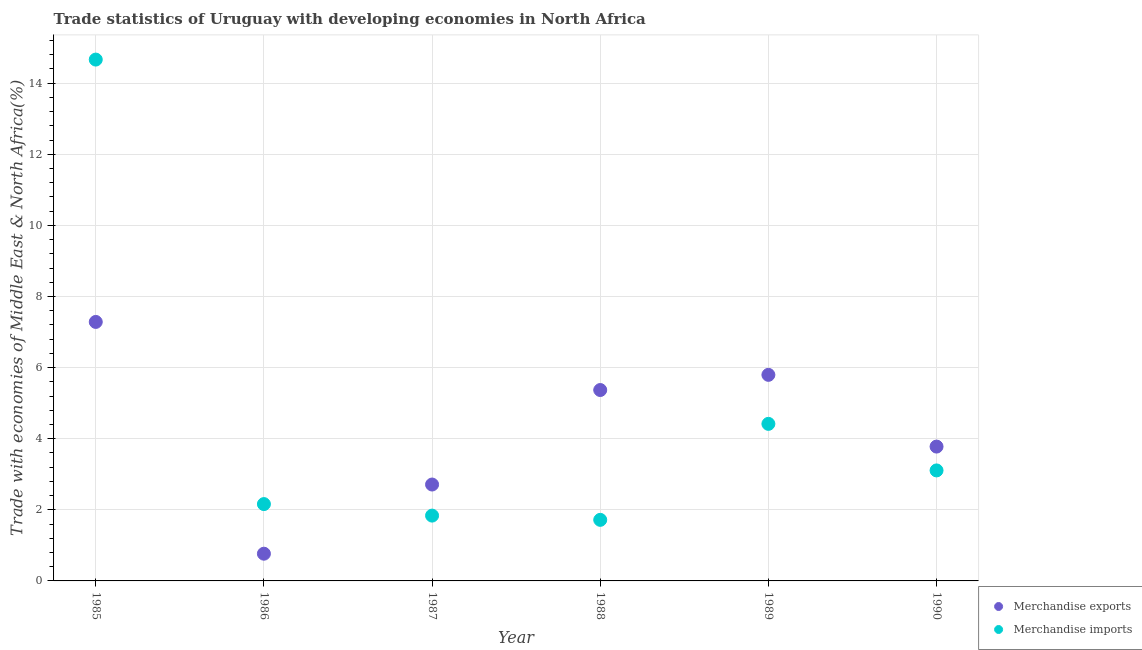What is the merchandise imports in 1987?
Your answer should be very brief. 1.84. Across all years, what is the maximum merchandise exports?
Offer a very short reply. 7.28. Across all years, what is the minimum merchandise exports?
Offer a very short reply. 0.77. In which year was the merchandise imports maximum?
Provide a succinct answer. 1985. What is the total merchandise exports in the graph?
Provide a succinct answer. 25.7. What is the difference between the merchandise exports in 1988 and that in 1990?
Offer a terse response. 1.59. What is the difference between the merchandise exports in 1989 and the merchandise imports in 1987?
Your answer should be compact. 3.96. What is the average merchandise imports per year?
Provide a succinct answer. 4.65. In the year 1985, what is the difference between the merchandise exports and merchandise imports?
Give a very brief answer. -7.38. In how many years, is the merchandise imports greater than 12 %?
Give a very brief answer. 1. What is the ratio of the merchandise imports in 1989 to that in 1990?
Keep it short and to the point. 1.42. Is the difference between the merchandise imports in 1988 and 1989 greater than the difference between the merchandise exports in 1988 and 1989?
Provide a succinct answer. No. What is the difference between the highest and the second highest merchandise exports?
Your response must be concise. 1.49. What is the difference between the highest and the lowest merchandise exports?
Your answer should be very brief. 6.52. Is the sum of the merchandise imports in 1987 and 1990 greater than the maximum merchandise exports across all years?
Offer a terse response. No. Does the merchandise imports monotonically increase over the years?
Ensure brevity in your answer.  No. Is the merchandise imports strictly less than the merchandise exports over the years?
Give a very brief answer. No. How many dotlines are there?
Provide a succinct answer. 2. How many years are there in the graph?
Offer a terse response. 6. What is the difference between two consecutive major ticks on the Y-axis?
Provide a succinct answer. 2. Does the graph contain grids?
Give a very brief answer. Yes. How many legend labels are there?
Offer a terse response. 2. What is the title of the graph?
Offer a very short reply. Trade statistics of Uruguay with developing economies in North Africa. Does "National Tourists" appear as one of the legend labels in the graph?
Keep it short and to the point. No. What is the label or title of the Y-axis?
Ensure brevity in your answer.  Trade with economies of Middle East & North Africa(%). What is the Trade with economies of Middle East & North Africa(%) in Merchandise exports in 1985?
Your answer should be compact. 7.28. What is the Trade with economies of Middle East & North Africa(%) of Merchandise imports in 1985?
Offer a terse response. 14.66. What is the Trade with economies of Middle East & North Africa(%) of Merchandise exports in 1986?
Offer a very short reply. 0.77. What is the Trade with economies of Middle East & North Africa(%) of Merchandise imports in 1986?
Give a very brief answer. 2.16. What is the Trade with economies of Middle East & North Africa(%) in Merchandise exports in 1987?
Your answer should be very brief. 2.71. What is the Trade with economies of Middle East & North Africa(%) of Merchandise imports in 1987?
Your answer should be compact. 1.84. What is the Trade with economies of Middle East & North Africa(%) of Merchandise exports in 1988?
Offer a very short reply. 5.37. What is the Trade with economies of Middle East & North Africa(%) of Merchandise imports in 1988?
Your answer should be very brief. 1.72. What is the Trade with economies of Middle East & North Africa(%) in Merchandise exports in 1989?
Ensure brevity in your answer.  5.8. What is the Trade with economies of Middle East & North Africa(%) in Merchandise imports in 1989?
Offer a terse response. 4.42. What is the Trade with economies of Middle East & North Africa(%) in Merchandise exports in 1990?
Provide a succinct answer. 3.78. What is the Trade with economies of Middle East & North Africa(%) in Merchandise imports in 1990?
Your answer should be compact. 3.11. Across all years, what is the maximum Trade with economies of Middle East & North Africa(%) of Merchandise exports?
Keep it short and to the point. 7.28. Across all years, what is the maximum Trade with economies of Middle East & North Africa(%) of Merchandise imports?
Your answer should be compact. 14.66. Across all years, what is the minimum Trade with economies of Middle East & North Africa(%) of Merchandise exports?
Your answer should be very brief. 0.77. Across all years, what is the minimum Trade with economies of Middle East & North Africa(%) of Merchandise imports?
Provide a succinct answer. 1.72. What is the total Trade with economies of Middle East & North Africa(%) of Merchandise exports in the graph?
Your answer should be compact. 25.7. What is the total Trade with economies of Middle East & North Africa(%) in Merchandise imports in the graph?
Your answer should be very brief. 27.9. What is the difference between the Trade with economies of Middle East & North Africa(%) in Merchandise exports in 1985 and that in 1986?
Your answer should be very brief. 6.52. What is the difference between the Trade with economies of Middle East & North Africa(%) in Merchandise imports in 1985 and that in 1986?
Ensure brevity in your answer.  12.5. What is the difference between the Trade with economies of Middle East & North Africa(%) of Merchandise exports in 1985 and that in 1987?
Offer a very short reply. 4.57. What is the difference between the Trade with economies of Middle East & North Africa(%) in Merchandise imports in 1985 and that in 1987?
Provide a short and direct response. 12.83. What is the difference between the Trade with economies of Middle East & North Africa(%) in Merchandise exports in 1985 and that in 1988?
Ensure brevity in your answer.  1.92. What is the difference between the Trade with economies of Middle East & North Africa(%) in Merchandise imports in 1985 and that in 1988?
Give a very brief answer. 12.95. What is the difference between the Trade with economies of Middle East & North Africa(%) in Merchandise exports in 1985 and that in 1989?
Offer a very short reply. 1.49. What is the difference between the Trade with economies of Middle East & North Africa(%) of Merchandise imports in 1985 and that in 1989?
Your answer should be compact. 10.25. What is the difference between the Trade with economies of Middle East & North Africa(%) in Merchandise exports in 1985 and that in 1990?
Your answer should be very brief. 3.51. What is the difference between the Trade with economies of Middle East & North Africa(%) of Merchandise imports in 1985 and that in 1990?
Your response must be concise. 11.56. What is the difference between the Trade with economies of Middle East & North Africa(%) of Merchandise exports in 1986 and that in 1987?
Your answer should be very brief. -1.95. What is the difference between the Trade with economies of Middle East & North Africa(%) of Merchandise imports in 1986 and that in 1987?
Your answer should be compact. 0.32. What is the difference between the Trade with economies of Middle East & North Africa(%) of Merchandise exports in 1986 and that in 1988?
Provide a short and direct response. -4.6. What is the difference between the Trade with economies of Middle East & North Africa(%) in Merchandise imports in 1986 and that in 1988?
Make the answer very short. 0.44. What is the difference between the Trade with economies of Middle East & North Africa(%) of Merchandise exports in 1986 and that in 1989?
Your answer should be compact. -5.03. What is the difference between the Trade with economies of Middle East & North Africa(%) in Merchandise imports in 1986 and that in 1989?
Your response must be concise. -2.26. What is the difference between the Trade with economies of Middle East & North Africa(%) of Merchandise exports in 1986 and that in 1990?
Your answer should be compact. -3.01. What is the difference between the Trade with economies of Middle East & North Africa(%) of Merchandise imports in 1986 and that in 1990?
Make the answer very short. -0.95. What is the difference between the Trade with economies of Middle East & North Africa(%) in Merchandise exports in 1987 and that in 1988?
Ensure brevity in your answer.  -2.66. What is the difference between the Trade with economies of Middle East & North Africa(%) of Merchandise imports in 1987 and that in 1988?
Your answer should be compact. 0.12. What is the difference between the Trade with economies of Middle East & North Africa(%) of Merchandise exports in 1987 and that in 1989?
Provide a succinct answer. -3.08. What is the difference between the Trade with economies of Middle East & North Africa(%) in Merchandise imports in 1987 and that in 1989?
Offer a terse response. -2.58. What is the difference between the Trade with economies of Middle East & North Africa(%) in Merchandise exports in 1987 and that in 1990?
Offer a very short reply. -1.07. What is the difference between the Trade with economies of Middle East & North Africa(%) in Merchandise imports in 1987 and that in 1990?
Your response must be concise. -1.27. What is the difference between the Trade with economies of Middle East & North Africa(%) of Merchandise exports in 1988 and that in 1989?
Make the answer very short. -0.43. What is the difference between the Trade with economies of Middle East & North Africa(%) in Merchandise imports in 1988 and that in 1989?
Make the answer very short. -2.7. What is the difference between the Trade with economies of Middle East & North Africa(%) of Merchandise exports in 1988 and that in 1990?
Ensure brevity in your answer.  1.59. What is the difference between the Trade with economies of Middle East & North Africa(%) of Merchandise imports in 1988 and that in 1990?
Give a very brief answer. -1.39. What is the difference between the Trade with economies of Middle East & North Africa(%) of Merchandise exports in 1989 and that in 1990?
Your answer should be compact. 2.02. What is the difference between the Trade with economies of Middle East & North Africa(%) in Merchandise imports in 1989 and that in 1990?
Your answer should be compact. 1.31. What is the difference between the Trade with economies of Middle East & North Africa(%) of Merchandise exports in 1985 and the Trade with economies of Middle East & North Africa(%) of Merchandise imports in 1986?
Your answer should be very brief. 5.12. What is the difference between the Trade with economies of Middle East & North Africa(%) of Merchandise exports in 1985 and the Trade with economies of Middle East & North Africa(%) of Merchandise imports in 1987?
Provide a short and direct response. 5.45. What is the difference between the Trade with economies of Middle East & North Africa(%) in Merchandise exports in 1985 and the Trade with economies of Middle East & North Africa(%) in Merchandise imports in 1988?
Give a very brief answer. 5.57. What is the difference between the Trade with economies of Middle East & North Africa(%) in Merchandise exports in 1985 and the Trade with economies of Middle East & North Africa(%) in Merchandise imports in 1989?
Your answer should be very brief. 2.87. What is the difference between the Trade with economies of Middle East & North Africa(%) in Merchandise exports in 1985 and the Trade with economies of Middle East & North Africa(%) in Merchandise imports in 1990?
Your answer should be very brief. 4.18. What is the difference between the Trade with economies of Middle East & North Africa(%) in Merchandise exports in 1986 and the Trade with economies of Middle East & North Africa(%) in Merchandise imports in 1987?
Your answer should be very brief. -1.07. What is the difference between the Trade with economies of Middle East & North Africa(%) in Merchandise exports in 1986 and the Trade with economies of Middle East & North Africa(%) in Merchandise imports in 1988?
Keep it short and to the point. -0.95. What is the difference between the Trade with economies of Middle East & North Africa(%) in Merchandise exports in 1986 and the Trade with economies of Middle East & North Africa(%) in Merchandise imports in 1989?
Provide a succinct answer. -3.65. What is the difference between the Trade with economies of Middle East & North Africa(%) in Merchandise exports in 1986 and the Trade with economies of Middle East & North Africa(%) in Merchandise imports in 1990?
Your answer should be very brief. -2.34. What is the difference between the Trade with economies of Middle East & North Africa(%) in Merchandise exports in 1987 and the Trade with economies of Middle East & North Africa(%) in Merchandise imports in 1988?
Offer a very short reply. 0.99. What is the difference between the Trade with economies of Middle East & North Africa(%) of Merchandise exports in 1987 and the Trade with economies of Middle East & North Africa(%) of Merchandise imports in 1989?
Offer a very short reply. -1.71. What is the difference between the Trade with economies of Middle East & North Africa(%) in Merchandise exports in 1987 and the Trade with economies of Middle East & North Africa(%) in Merchandise imports in 1990?
Give a very brief answer. -0.4. What is the difference between the Trade with economies of Middle East & North Africa(%) of Merchandise exports in 1988 and the Trade with economies of Middle East & North Africa(%) of Merchandise imports in 1990?
Make the answer very short. 2.26. What is the difference between the Trade with economies of Middle East & North Africa(%) of Merchandise exports in 1989 and the Trade with economies of Middle East & North Africa(%) of Merchandise imports in 1990?
Provide a short and direct response. 2.69. What is the average Trade with economies of Middle East & North Africa(%) in Merchandise exports per year?
Keep it short and to the point. 4.28. What is the average Trade with economies of Middle East & North Africa(%) of Merchandise imports per year?
Provide a short and direct response. 4.65. In the year 1985, what is the difference between the Trade with economies of Middle East & North Africa(%) in Merchandise exports and Trade with economies of Middle East & North Africa(%) in Merchandise imports?
Offer a very short reply. -7.38. In the year 1986, what is the difference between the Trade with economies of Middle East & North Africa(%) in Merchandise exports and Trade with economies of Middle East & North Africa(%) in Merchandise imports?
Your answer should be very brief. -1.4. In the year 1987, what is the difference between the Trade with economies of Middle East & North Africa(%) in Merchandise exports and Trade with economies of Middle East & North Africa(%) in Merchandise imports?
Your response must be concise. 0.87. In the year 1988, what is the difference between the Trade with economies of Middle East & North Africa(%) in Merchandise exports and Trade with economies of Middle East & North Africa(%) in Merchandise imports?
Your answer should be compact. 3.65. In the year 1989, what is the difference between the Trade with economies of Middle East & North Africa(%) of Merchandise exports and Trade with economies of Middle East & North Africa(%) of Merchandise imports?
Ensure brevity in your answer.  1.38. In the year 1990, what is the difference between the Trade with economies of Middle East & North Africa(%) of Merchandise exports and Trade with economies of Middle East & North Africa(%) of Merchandise imports?
Offer a terse response. 0.67. What is the ratio of the Trade with economies of Middle East & North Africa(%) in Merchandise exports in 1985 to that in 1986?
Your answer should be very brief. 9.51. What is the ratio of the Trade with economies of Middle East & North Africa(%) of Merchandise imports in 1985 to that in 1986?
Provide a short and direct response. 6.79. What is the ratio of the Trade with economies of Middle East & North Africa(%) in Merchandise exports in 1985 to that in 1987?
Provide a succinct answer. 2.69. What is the ratio of the Trade with economies of Middle East & North Africa(%) in Merchandise imports in 1985 to that in 1987?
Offer a very short reply. 7.98. What is the ratio of the Trade with economies of Middle East & North Africa(%) in Merchandise exports in 1985 to that in 1988?
Provide a succinct answer. 1.36. What is the ratio of the Trade with economies of Middle East & North Africa(%) of Merchandise imports in 1985 to that in 1988?
Give a very brief answer. 8.54. What is the ratio of the Trade with economies of Middle East & North Africa(%) in Merchandise exports in 1985 to that in 1989?
Offer a very short reply. 1.26. What is the ratio of the Trade with economies of Middle East & North Africa(%) of Merchandise imports in 1985 to that in 1989?
Your answer should be very brief. 3.32. What is the ratio of the Trade with economies of Middle East & North Africa(%) in Merchandise exports in 1985 to that in 1990?
Provide a short and direct response. 1.93. What is the ratio of the Trade with economies of Middle East & North Africa(%) of Merchandise imports in 1985 to that in 1990?
Your response must be concise. 4.72. What is the ratio of the Trade with economies of Middle East & North Africa(%) of Merchandise exports in 1986 to that in 1987?
Make the answer very short. 0.28. What is the ratio of the Trade with economies of Middle East & North Africa(%) of Merchandise imports in 1986 to that in 1987?
Your response must be concise. 1.18. What is the ratio of the Trade with economies of Middle East & North Africa(%) of Merchandise exports in 1986 to that in 1988?
Your answer should be very brief. 0.14. What is the ratio of the Trade with economies of Middle East & North Africa(%) of Merchandise imports in 1986 to that in 1988?
Give a very brief answer. 1.26. What is the ratio of the Trade with economies of Middle East & North Africa(%) of Merchandise exports in 1986 to that in 1989?
Provide a short and direct response. 0.13. What is the ratio of the Trade with economies of Middle East & North Africa(%) in Merchandise imports in 1986 to that in 1989?
Give a very brief answer. 0.49. What is the ratio of the Trade with economies of Middle East & North Africa(%) of Merchandise exports in 1986 to that in 1990?
Keep it short and to the point. 0.2. What is the ratio of the Trade with economies of Middle East & North Africa(%) in Merchandise imports in 1986 to that in 1990?
Give a very brief answer. 0.7. What is the ratio of the Trade with economies of Middle East & North Africa(%) in Merchandise exports in 1987 to that in 1988?
Your answer should be compact. 0.5. What is the ratio of the Trade with economies of Middle East & North Africa(%) of Merchandise imports in 1987 to that in 1988?
Keep it short and to the point. 1.07. What is the ratio of the Trade with economies of Middle East & North Africa(%) of Merchandise exports in 1987 to that in 1989?
Your answer should be compact. 0.47. What is the ratio of the Trade with economies of Middle East & North Africa(%) of Merchandise imports in 1987 to that in 1989?
Provide a short and direct response. 0.42. What is the ratio of the Trade with economies of Middle East & North Africa(%) of Merchandise exports in 1987 to that in 1990?
Provide a short and direct response. 0.72. What is the ratio of the Trade with economies of Middle East & North Africa(%) in Merchandise imports in 1987 to that in 1990?
Your answer should be very brief. 0.59. What is the ratio of the Trade with economies of Middle East & North Africa(%) of Merchandise exports in 1988 to that in 1989?
Keep it short and to the point. 0.93. What is the ratio of the Trade with economies of Middle East & North Africa(%) of Merchandise imports in 1988 to that in 1989?
Offer a very short reply. 0.39. What is the ratio of the Trade with economies of Middle East & North Africa(%) in Merchandise exports in 1988 to that in 1990?
Your response must be concise. 1.42. What is the ratio of the Trade with economies of Middle East & North Africa(%) of Merchandise imports in 1988 to that in 1990?
Your answer should be very brief. 0.55. What is the ratio of the Trade with economies of Middle East & North Africa(%) of Merchandise exports in 1989 to that in 1990?
Offer a very short reply. 1.53. What is the ratio of the Trade with economies of Middle East & North Africa(%) in Merchandise imports in 1989 to that in 1990?
Keep it short and to the point. 1.42. What is the difference between the highest and the second highest Trade with economies of Middle East & North Africa(%) in Merchandise exports?
Offer a terse response. 1.49. What is the difference between the highest and the second highest Trade with economies of Middle East & North Africa(%) of Merchandise imports?
Keep it short and to the point. 10.25. What is the difference between the highest and the lowest Trade with economies of Middle East & North Africa(%) of Merchandise exports?
Ensure brevity in your answer.  6.52. What is the difference between the highest and the lowest Trade with economies of Middle East & North Africa(%) in Merchandise imports?
Provide a short and direct response. 12.95. 